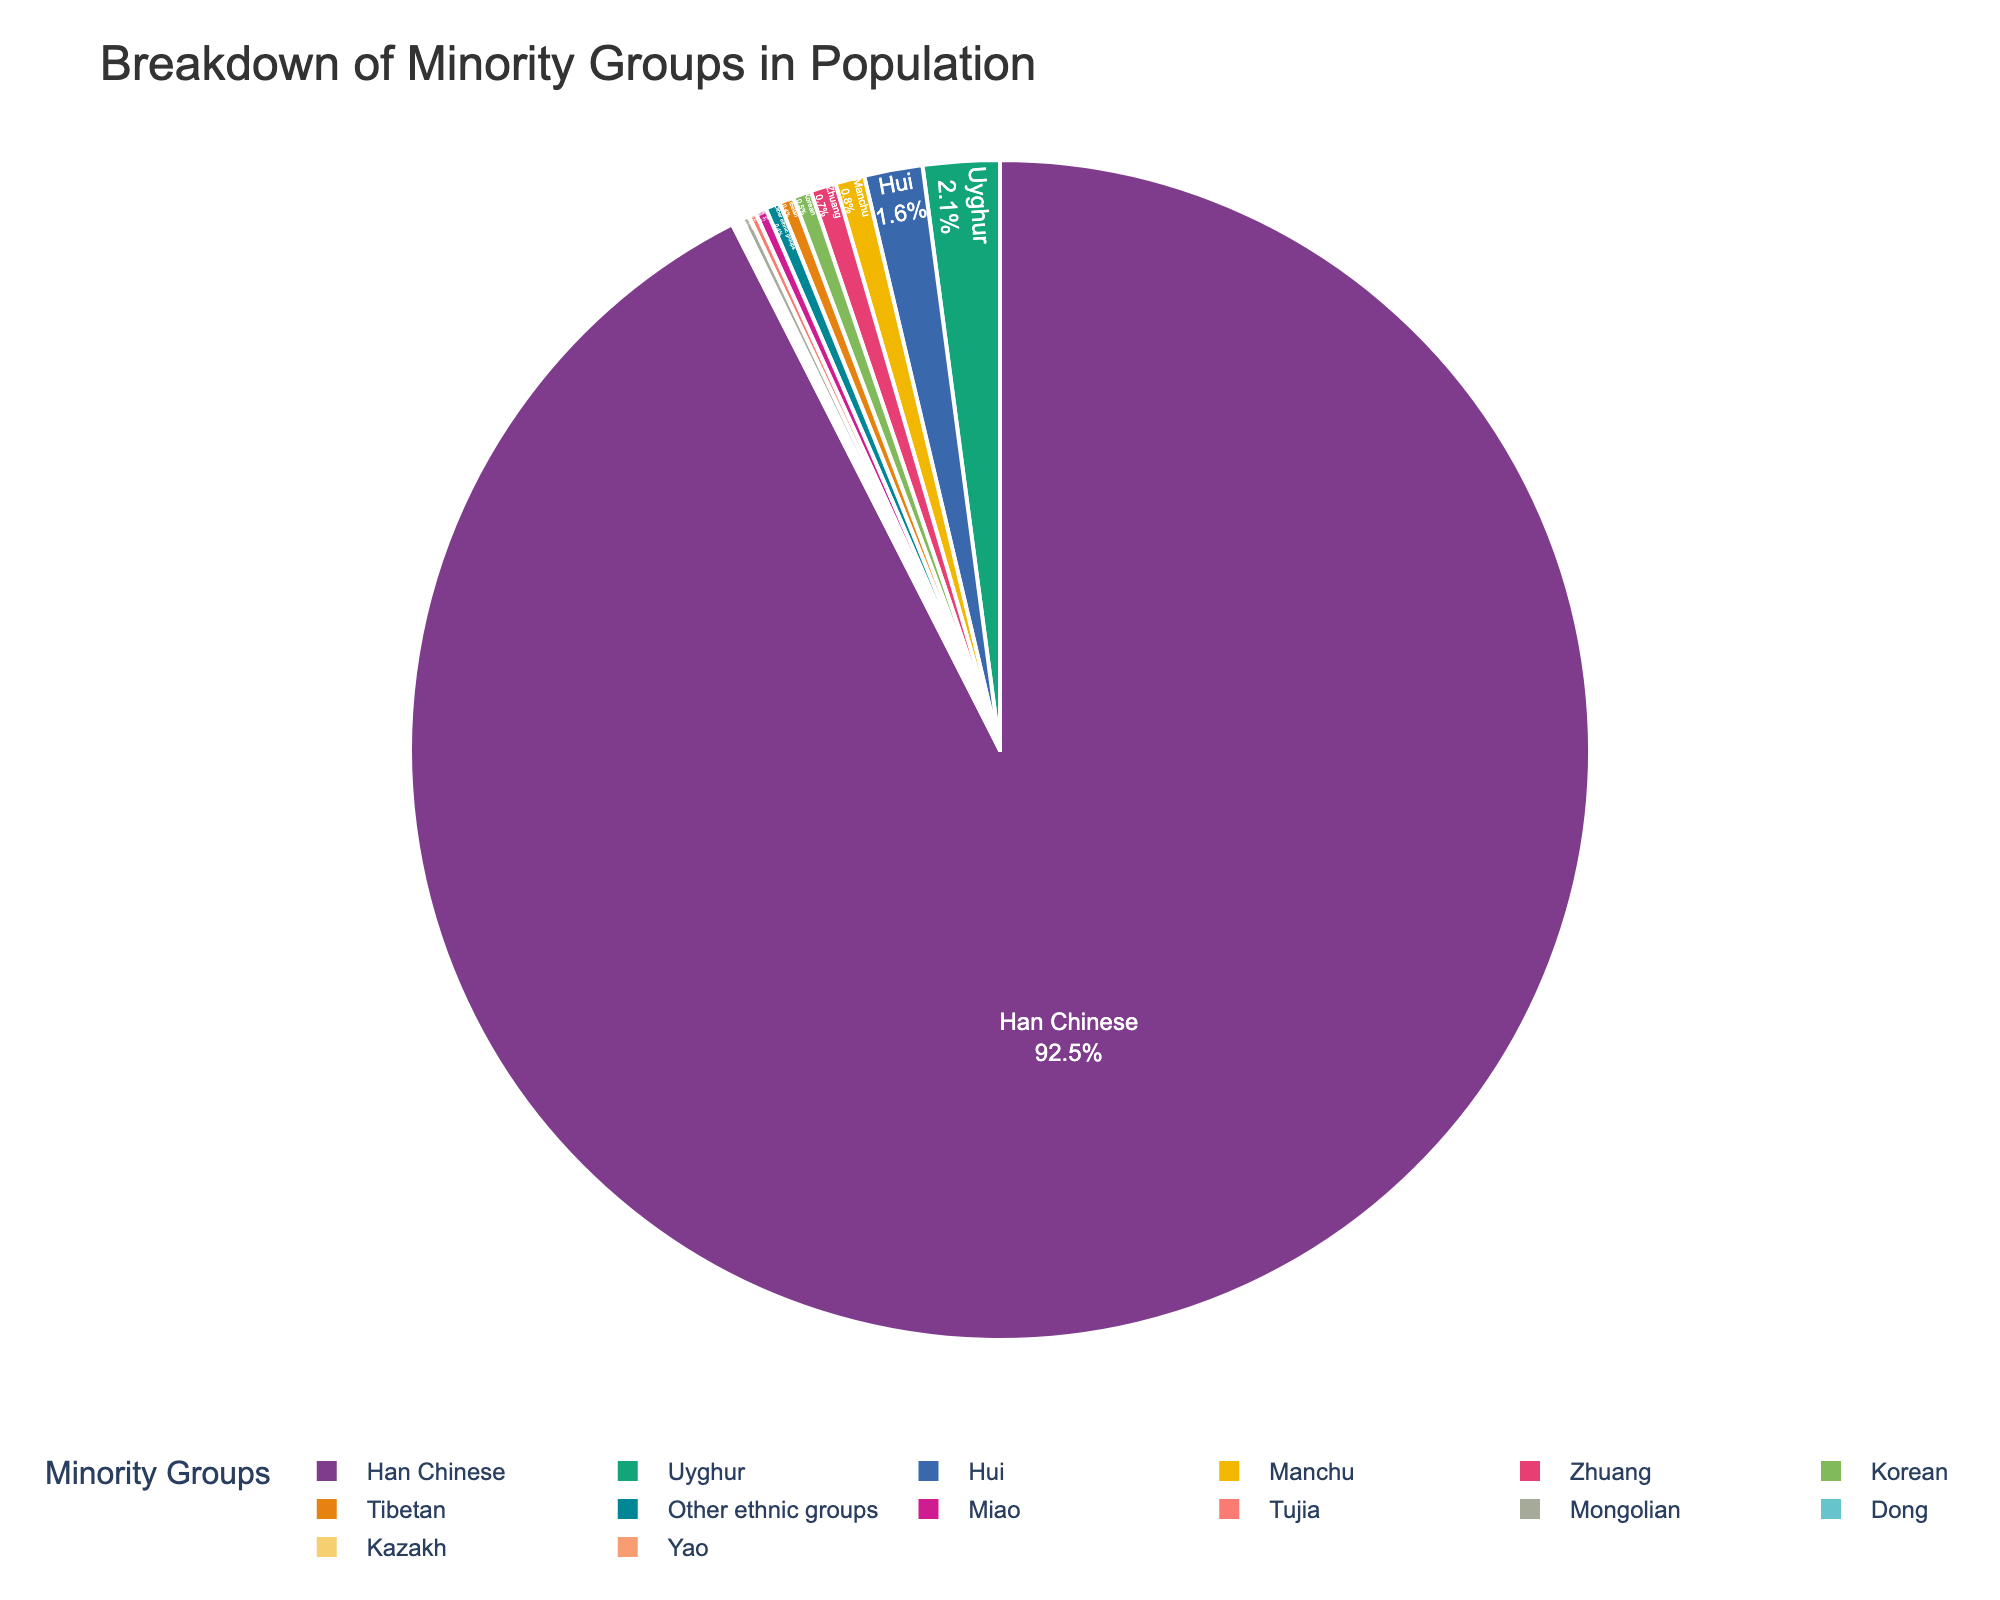Which minority group constitutes the largest percentage? Han Chinese constitute 92.5% of the population, which is the largest percentage.
Answer: Han Chinese Which two minority groups have the smallest percentages, and what are their combined percentages? The Dong and Kazakh groups each have the smallest percentage at 0.1%. Their combined percentage is 0.1% + 0.1% = 0.2%.
Answer: Dong and Kazakh, 0.2% Is the percentage of Uyghur in the population more than three times the percentage of Hui? Uyghur constitutes 2.1%, and Hui constitutes 1.6%. 2.1% is more than three times 1.6% (3 * 1.6% = 4.8%), so the answer is no.
Answer: No What is the total percentage of all groups that constitute less than 1% of the population? Add percentages of Manchu (0.8%), Zhuang (0.7%), Korean (0.5%), Tibetan (0.4%), Miao (0.3%), Tujia (0.2%), Mongolian (0.2%), Dong (0.1%), Kazakh (0.1%), Yao (0.1%), and Other ethnic groups (0.4%) = 3.8%
Answer: 3.8% Which minority group has the second-largest percentage in the population, and what is that percentage? Uyghur has the second-largest percentage in the population at 2.1%.
Answer: Uyghur, 2.1% How many minority groups contribute to a combined percentage of exactly 3%? Manchu (0.8%), Zhuang (0.7%), Korean (0.5%), Tibetan (0.4%), Miao (0.3%), Tujia (0.2%), Mongolian (0.2%), Dong (0.1%), Kazakh (0.1%), Yao (0.1%), and Other ethnic groups (0.4%) add up to 3.8%. The first few groups adding up to approximately 3% are Manchu, Zhuang, Korean, Tibetan, and Miao, which sum up to 2.7%, and then adding Tujia gets close to 2.9%.
Answer: 6 What fraction of the population is not Han Chinese? Subtract the percentage of Han Chinese from 100%: 100% - 92.5% = 7.5%
Answer: 7.5% Among the groups that each constitute less than 1% of the population, which group has the highest percentage, and what is it? Manchu has the highest percentage among groups constituting less than 1% at 0.8%.
Answer: Manchu, 0.8% Does the combined percentage of Hui and Korean groups exceed that of Uyghur? Hui (1.6%) + Korean (0.5%) = 2.1%. This is equal to the percentage of Uyghur, which is 2.1%.
Answer: No What is the median value of the minority groups' percentages? Order the percentages: 0.1%, 0.1%, 0.1%, 0.2%, 0.2%, 0.3%, 0.4%, 0.4%, 0.5%, 0.7%, 0.8%, 1.6%, 2.1%. The median value is the 7th value in the list (which is 0.4%).
Answer: 0.4% 